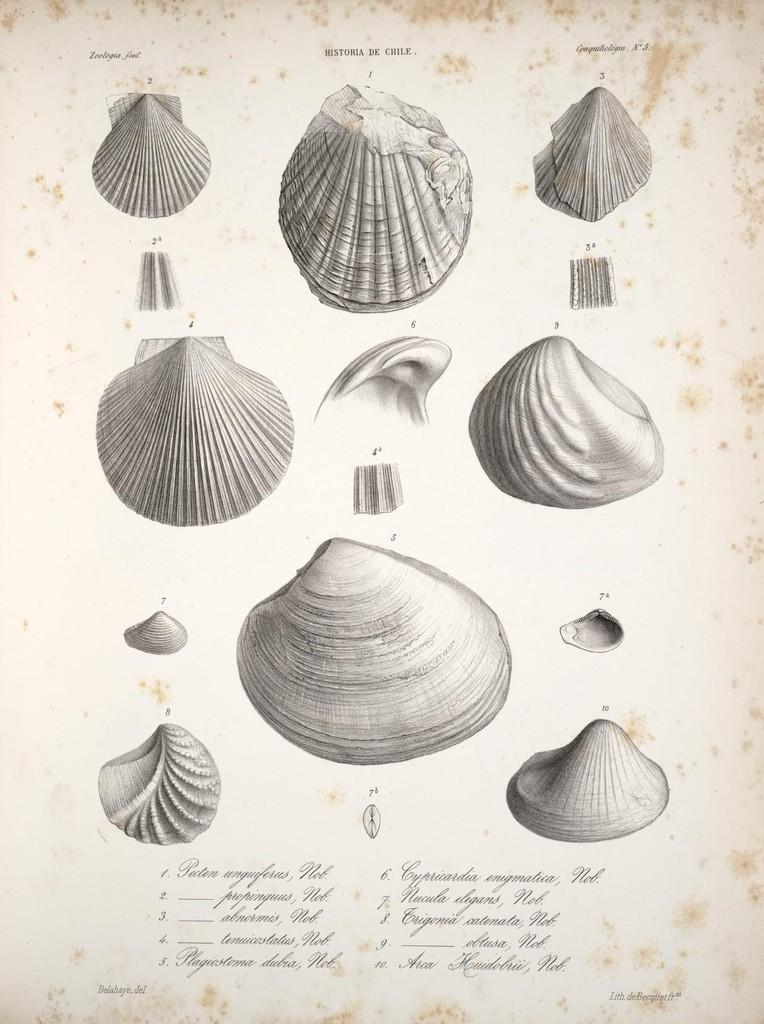Please provide a concise description of this image. There is a page in the image on, which there are types of shells and text on it. 